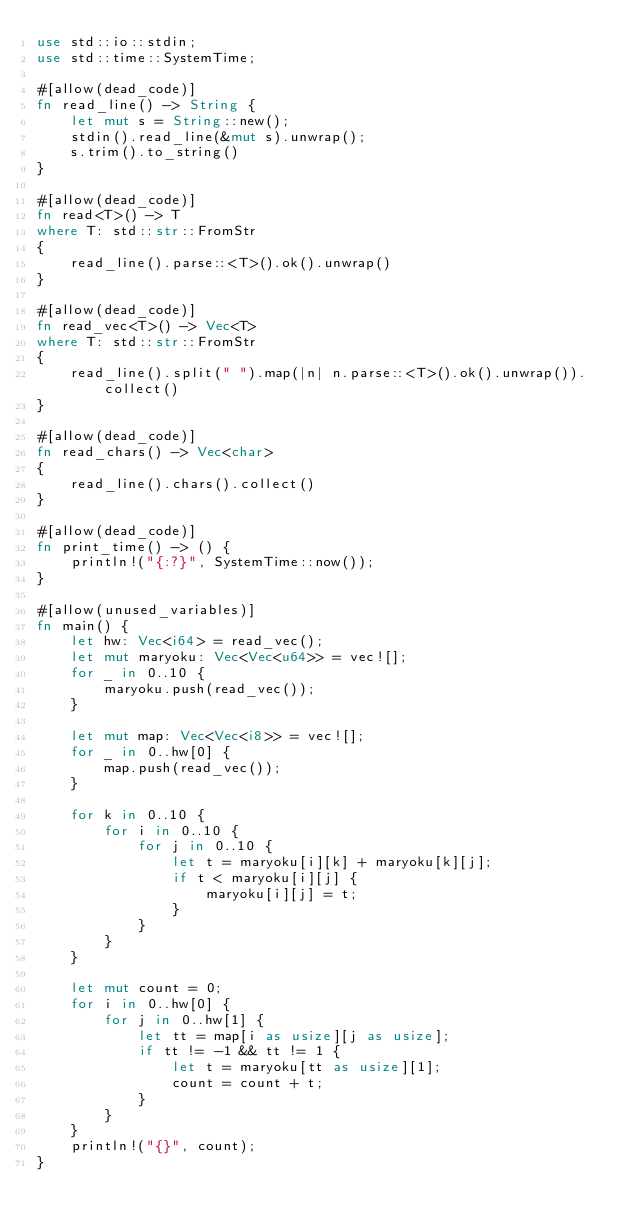Convert code to text. <code><loc_0><loc_0><loc_500><loc_500><_Rust_>use std::io::stdin;
use std::time::SystemTime;

#[allow(dead_code)]
fn read_line() -> String {
    let mut s = String::new();
    stdin().read_line(&mut s).unwrap();
    s.trim().to_string()
}

#[allow(dead_code)]
fn read<T>() -> T
where T: std::str::FromStr
{
    read_line().parse::<T>().ok().unwrap()
}

#[allow(dead_code)]
fn read_vec<T>() -> Vec<T>
where T: std::str::FromStr
{
    read_line().split(" ").map(|n| n.parse::<T>().ok().unwrap()).collect()
}

#[allow(dead_code)]
fn read_chars() -> Vec<char>
{
    read_line().chars().collect()
}

#[allow(dead_code)]
fn print_time() -> () {
    println!("{:?}", SystemTime::now());
}

#[allow(unused_variables)]
fn main() {
    let hw: Vec<i64> = read_vec();
    let mut maryoku: Vec<Vec<u64>> = vec![];
    for _ in 0..10 {
        maryoku.push(read_vec());
    }
    
    let mut map: Vec<Vec<i8>> = vec![];
    for _ in 0..hw[0] {
        map.push(read_vec());
    }
    
    for k in 0..10 {
        for i in 0..10 {
            for j in 0..10 {
                let t = maryoku[i][k] + maryoku[k][j];
                if t < maryoku[i][j] {
                    maryoku[i][j] = t;
                }
            }
        }
    }
    
    let mut count = 0;
    for i in 0..hw[0] {
        for j in 0..hw[1] {
            let tt = map[i as usize][j as usize];
            if tt != -1 && tt != 1 {
                let t = maryoku[tt as usize][1];
                count = count + t;
            }
        }
    }
    println!("{}", count);
}
</code> 